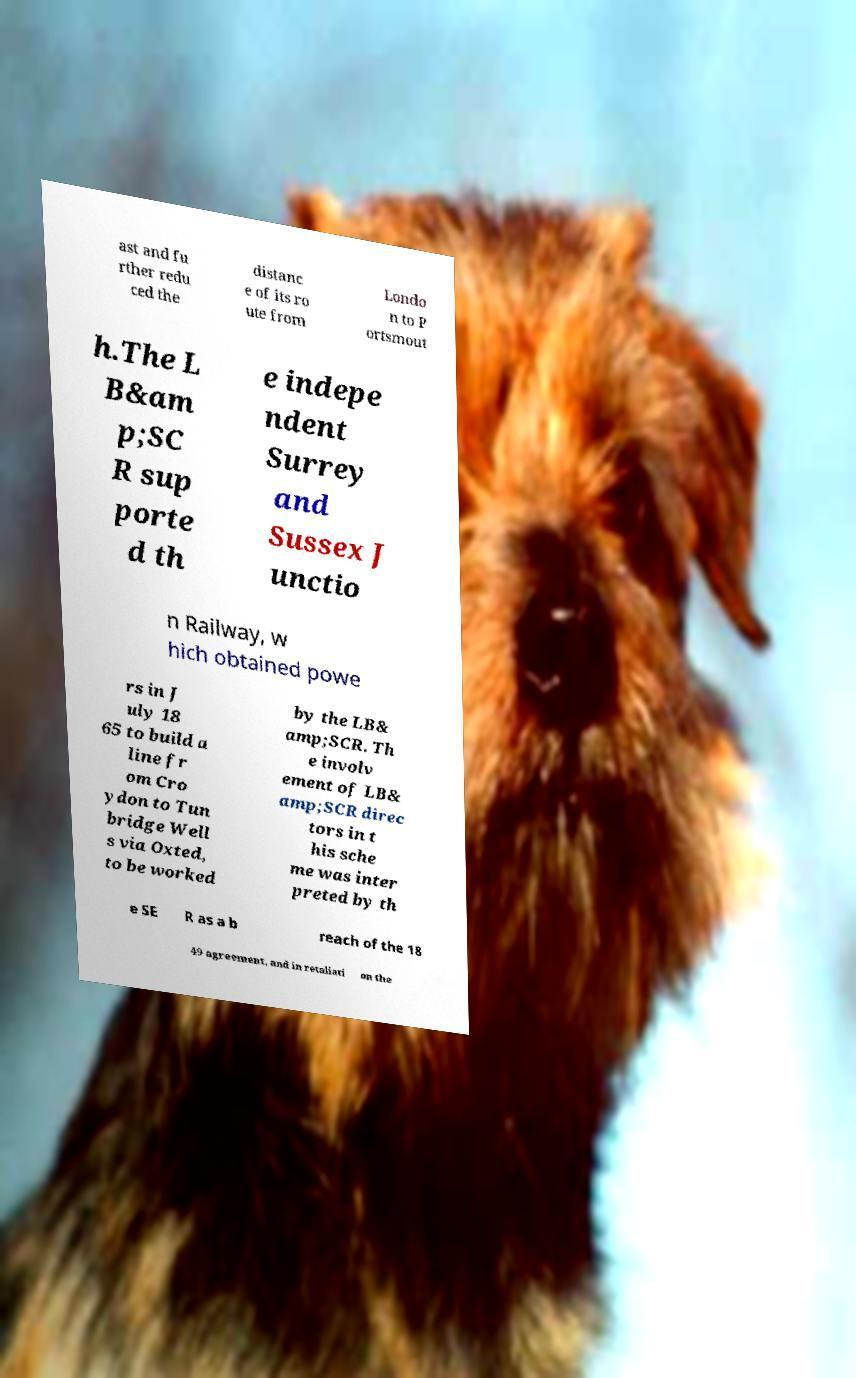Can you accurately transcribe the text from the provided image for me? ast and fu rther redu ced the distanc e of its ro ute from Londo n to P ortsmout h.The L B&am p;SC R sup porte d th e indepe ndent Surrey and Sussex J unctio n Railway, w hich obtained powe rs in J uly 18 65 to build a line fr om Cro ydon to Tun bridge Well s via Oxted, to be worked by the LB& amp;SCR. Th e involv ement of LB& amp;SCR direc tors in t his sche me was inter preted by th e SE R as a b reach of the 18 49 agreement, and in retaliati on the 